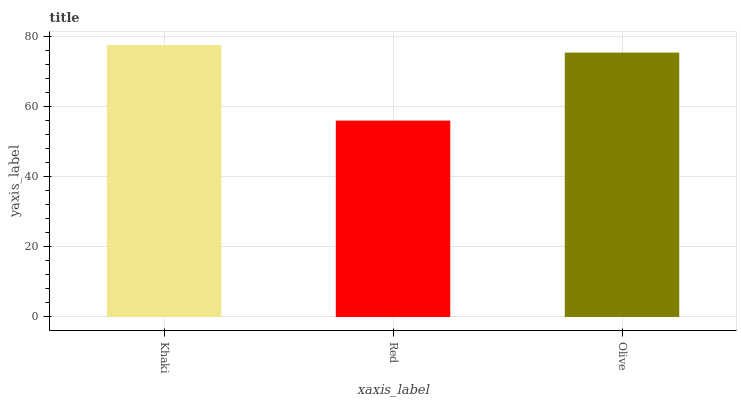Is Red the minimum?
Answer yes or no. Yes. Is Khaki the maximum?
Answer yes or no. Yes. Is Olive the minimum?
Answer yes or no. No. Is Olive the maximum?
Answer yes or no. No. Is Olive greater than Red?
Answer yes or no. Yes. Is Red less than Olive?
Answer yes or no. Yes. Is Red greater than Olive?
Answer yes or no. No. Is Olive less than Red?
Answer yes or no. No. Is Olive the high median?
Answer yes or no. Yes. Is Olive the low median?
Answer yes or no. Yes. Is Red the high median?
Answer yes or no. No. Is Khaki the low median?
Answer yes or no. No. 